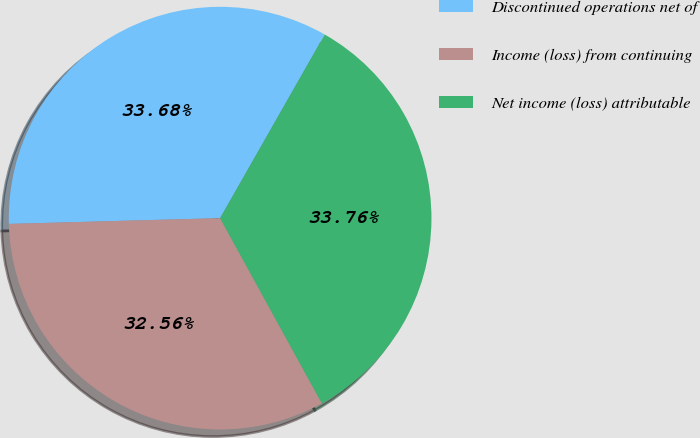Convert chart to OTSL. <chart><loc_0><loc_0><loc_500><loc_500><pie_chart><fcel>Discontinued operations net of<fcel>Income (loss) from continuing<fcel>Net income (loss) attributable<nl><fcel>33.68%<fcel>32.56%<fcel>33.76%<nl></chart> 